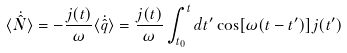<formula> <loc_0><loc_0><loc_500><loc_500>\langle \dot { \hat { N } } \rangle = - \frac { j ( t ) } { \omega } \langle \dot { \hat { q } } \rangle = \frac { j ( t ) } { \omega } \int _ { t _ { 0 } } ^ { t } d t ^ { \prime } \cos [ \omega ( t - t ^ { \prime } ) ] j ( t ^ { \prime } )</formula> 